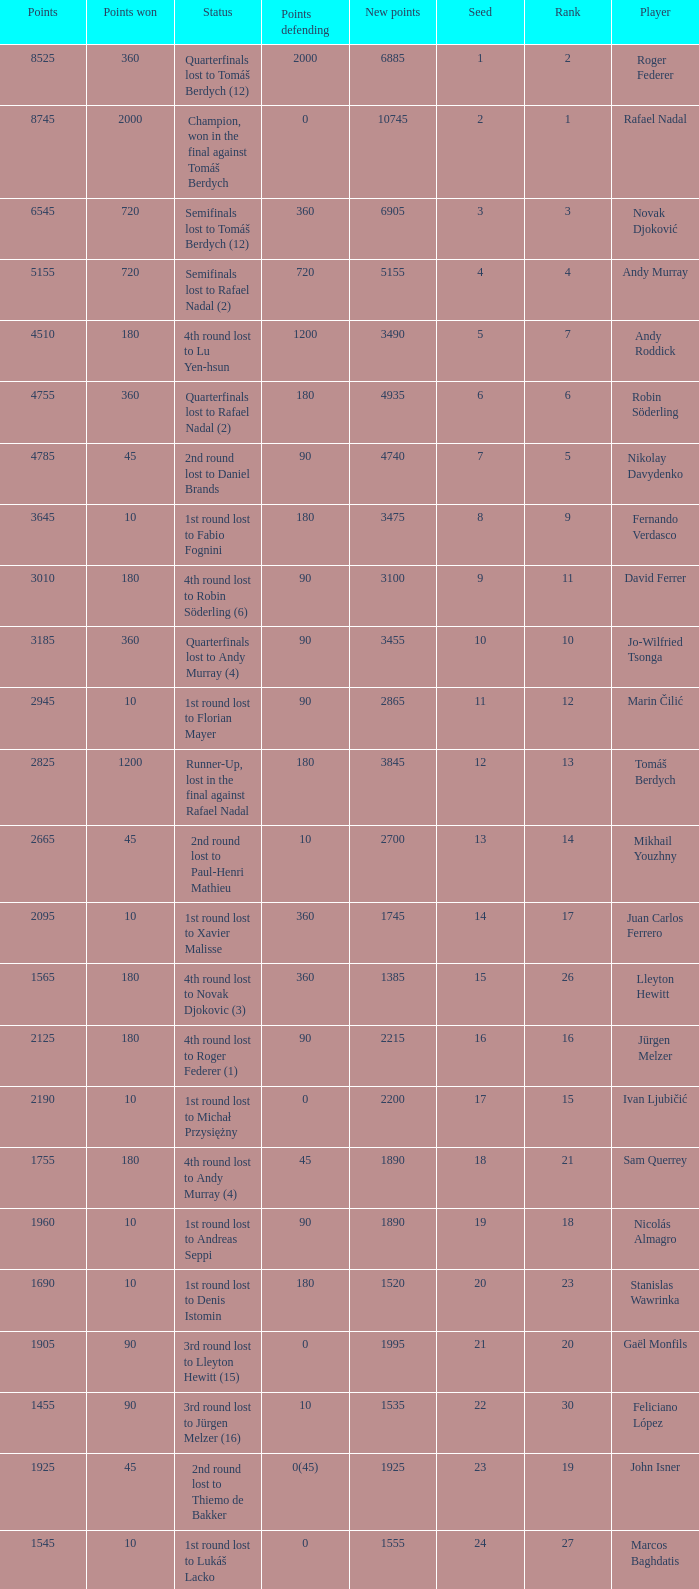Name the number of points defending for 1075 1.0. 